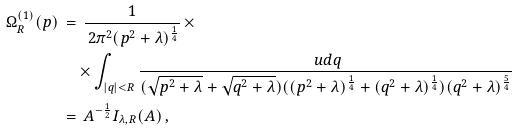Convert formula to latex. <formula><loc_0><loc_0><loc_500><loc_500>\Omega _ { R } ^ { ( 1 ) } ( p ) \, & = \, \frac { 1 } { \, 2 \pi ^ { 2 } ( p ^ { 2 } + \lambda ) ^ { \frac { 1 } { 4 } } } \, \times \\ & \quad \times \int _ { | q | < R } \frac { \ u d q } { ( \sqrt { p ^ { 2 } + \lambda } + \sqrt { q ^ { 2 } + \lambda } ) ( ( p ^ { 2 } + \lambda ) ^ { \frac { 1 } { 4 } } + ( q ^ { 2 } + \lambda ) ^ { \frac { 1 } { 4 } } ) ( q ^ { 2 } + \lambda ) ^ { \frac { 5 } { 4 } } } \\ & = \, A ^ { - \frac { 1 } { 2 } } I _ { \lambda , R } ( A ) \, ,</formula> 